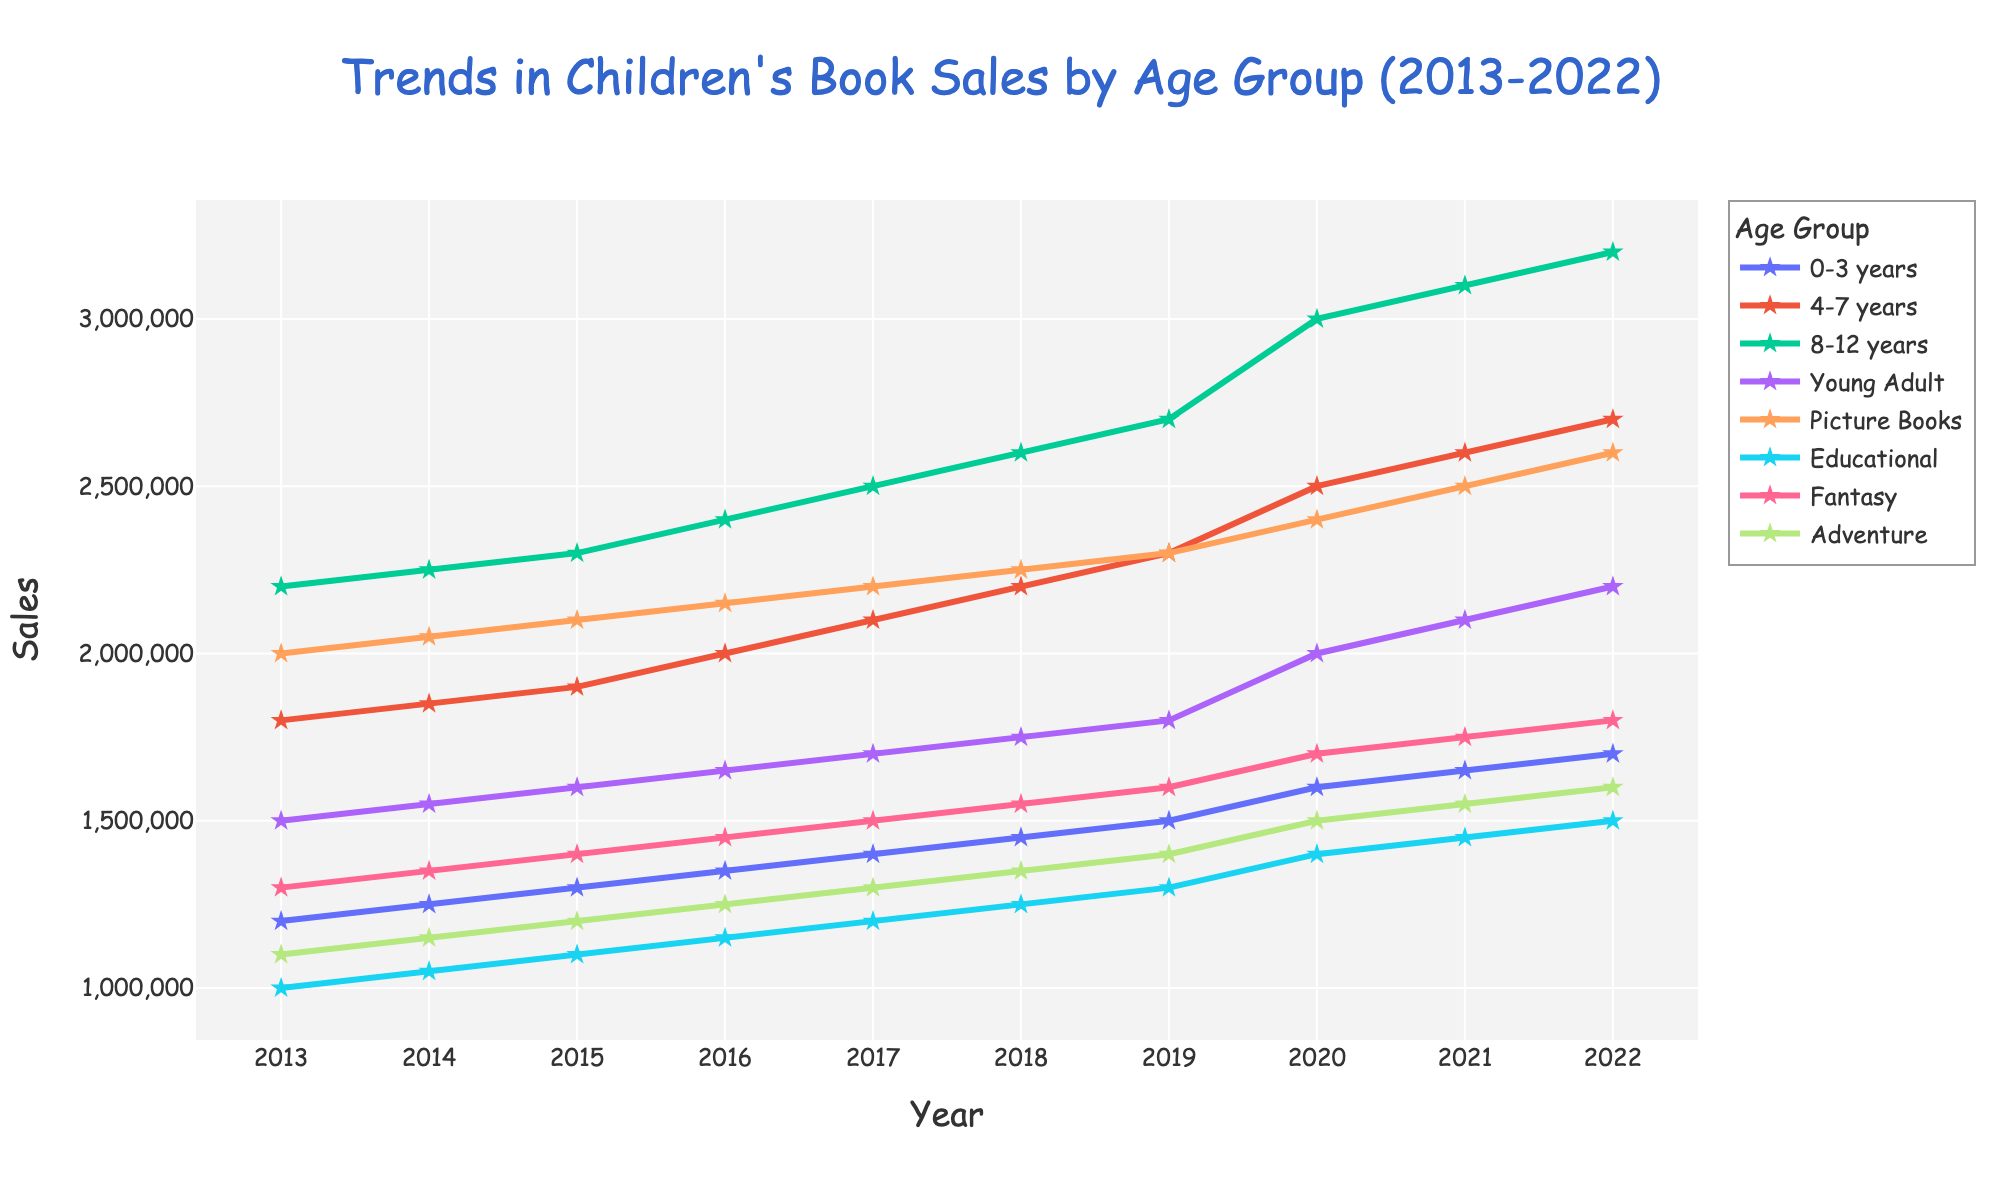What age group showed the highest sales in 2022? By examining the line chart for the sales data in the year 2022, the 8-12 years age group is at the highest point.
Answer: 8-12 years What was the difference in sales between the 0-3 years and Young Adult age groups in 2015? In 2015, the sales for the 0-3 years age group were 1,300,000, and for the Young Adult age group, it was 1,600,000. The difference is 1,600,000 - 1,300,000 = 300,000.
Answer: 300,000 Which age group experienced the most significant growth in sales over the decade? By comparing the slopes of the lines, the 8-12 years age group had a sales increase from 2,200,000 in 2013 to 3,200,000 in 2022, showing the largest increase in absolute terms.
Answer: 8-12 years Did any age group's sales remain constant over the years? By examining the trends of the lines, none of the age group lines display a flat or horizontal line, indicating that no age group's sales remained constant.
Answer: No Which age group showed the least growth in sales from 2013 to 2022? By evaluating the differences in sales from 2013 to 2022, the Educational age group grew from 1,000,000 to 1,500,000, showing the smallest growth of 500,000.
Answer: Educational In which year did sales for the 4-7 years age group surpass 2,000,000? By following the line upward and checking the year labels, sales for the 4-7 years age group first surpass 2,000,000 in 2016.
Answer: 2016 What's the average sales figure for the Picture Books age group over the decade? Summing up the sales data for Picture Books over the years 2013 to 2022 (2,000,000 + 2,050,000 + 2,100,000 + 2,150,000 + 2,200,000 + 2,250,000 + 2,300,000 + 2,400,000 + 2,500,000 + 2,600,000) gives 22,850,000. The average is 22,850,000 / 10.
Answer: 2,285,000 Which year saw a visible surge in sales across most age groups? Comparing the slopes of the lines, there appears to be a visible surge in 2020 for most age groups where the lines tend to spike.
Answer: 2020 Are the sales trends for Fantasy and Adventure similar? By comparing the shape and direction of the two lines closely, both the Fantasy and Adventure age groups show similar upward trends but not identical patterns.
Answer: Similar 